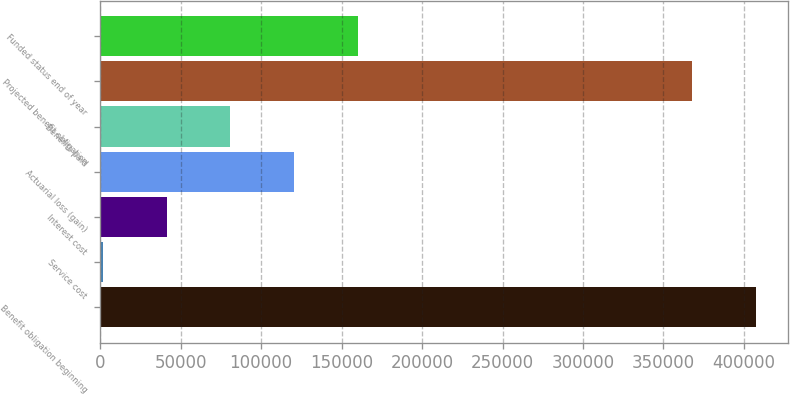<chart> <loc_0><loc_0><loc_500><loc_500><bar_chart><fcel>Benefit obligation beginning<fcel>Service cost<fcel>Interest cost<fcel>Actuarial loss (gain)<fcel>Benefits paid<fcel>Projected benefit obligation<fcel>Funded status end of year<nl><fcel>407268<fcel>1819<fcel>41355.5<fcel>120428<fcel>80892<fcel>367731<fcel>159965<nl></chart> 